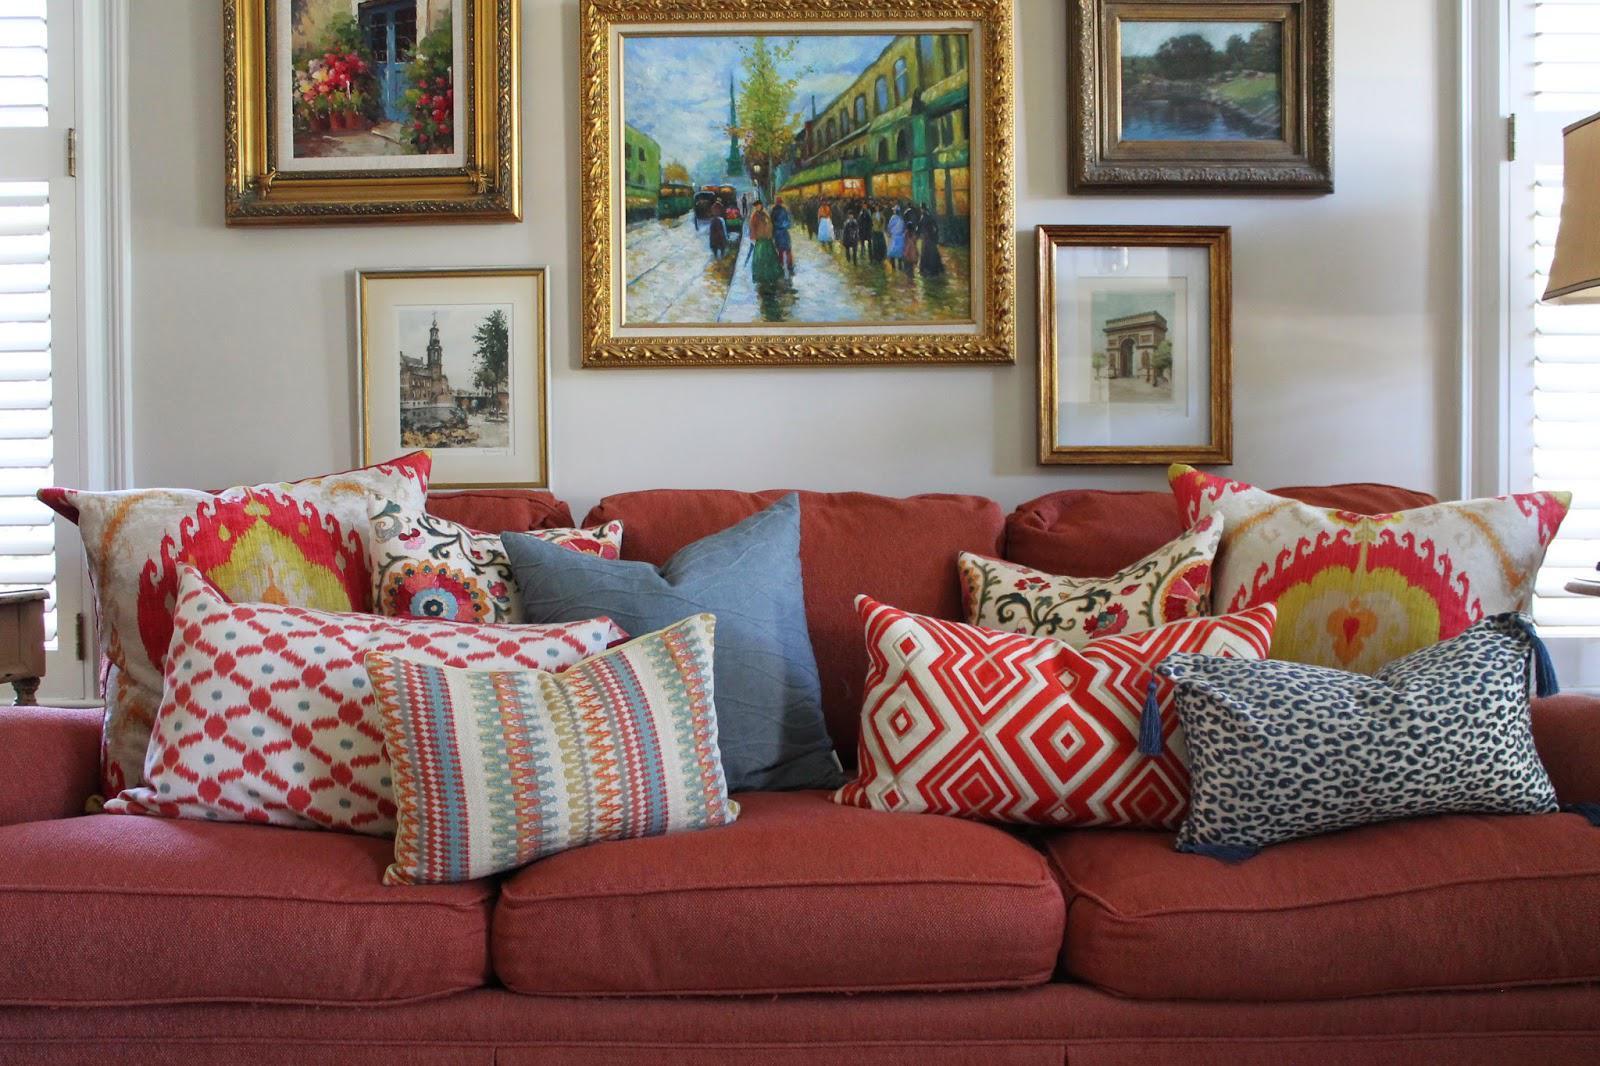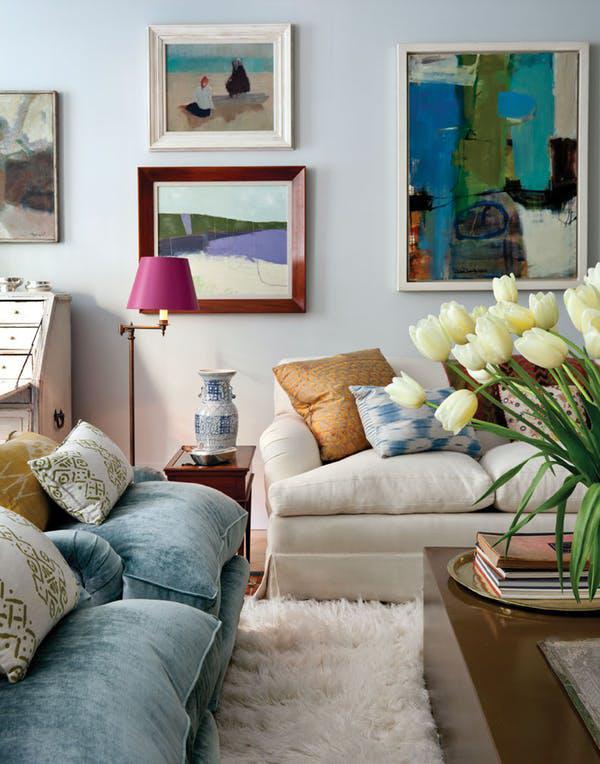The first image is the image on the left, the second image is the image on the right. Evaluate the accuracy of this statement regarding the images: "Flowers in a vase are visible in the image on the right.". Is it true? Answer yes or no. Yes. 